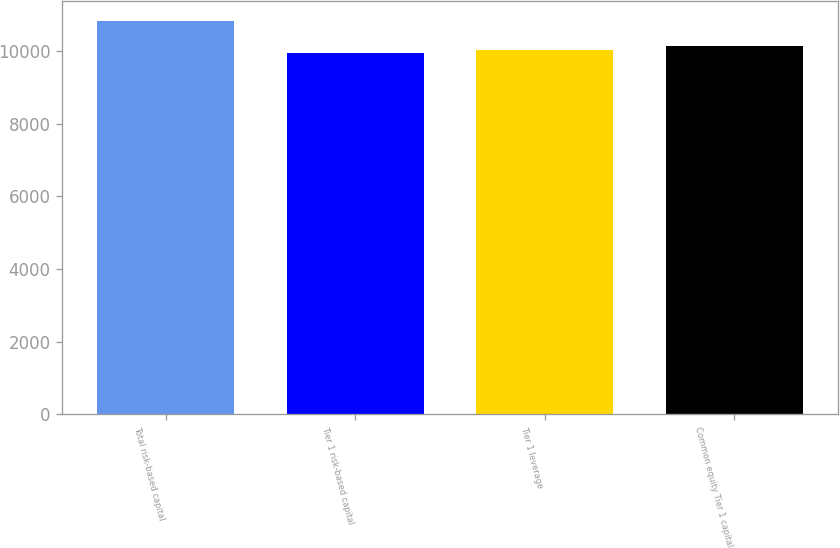<chart> <loc_0><loc_0><loc_500><loc_500><bar_chart><fcel>Total risk-based capital<fcel>Tier 1 risk-based capital<fcel>Tier 1 leverage<fcel>Common equity Tier 1 capital<nl><fcel>10842<fcel>9958<fcel>10046.4<fcel>10134.8<nl></chart> 